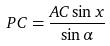Convert formula to latex. <formula><loc_0><loc_0><loc_500><loc_500>P C = \frac { A C \sin x } { \sin \alpha }</formula> 